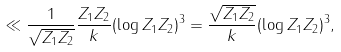Convert formula to latex. <formula><loc_0><loc_0><loc_500><loc_500>\ll \frac { 1 } { \sqrt { Z _ { 1 } Z _ { 2 } } } \frac { Z _ { 1 } Z _ { 2 } } { k } ( \log Z _ { 1 } Z _ { 2 } ) ^ { 3 } = \frac { \sqrt { Z _ { 1 } Z _ { 2 } } } { k } ( \log Z _ { 1 } Z _ { 2 } ) ^ { 3 } ,</formula> 